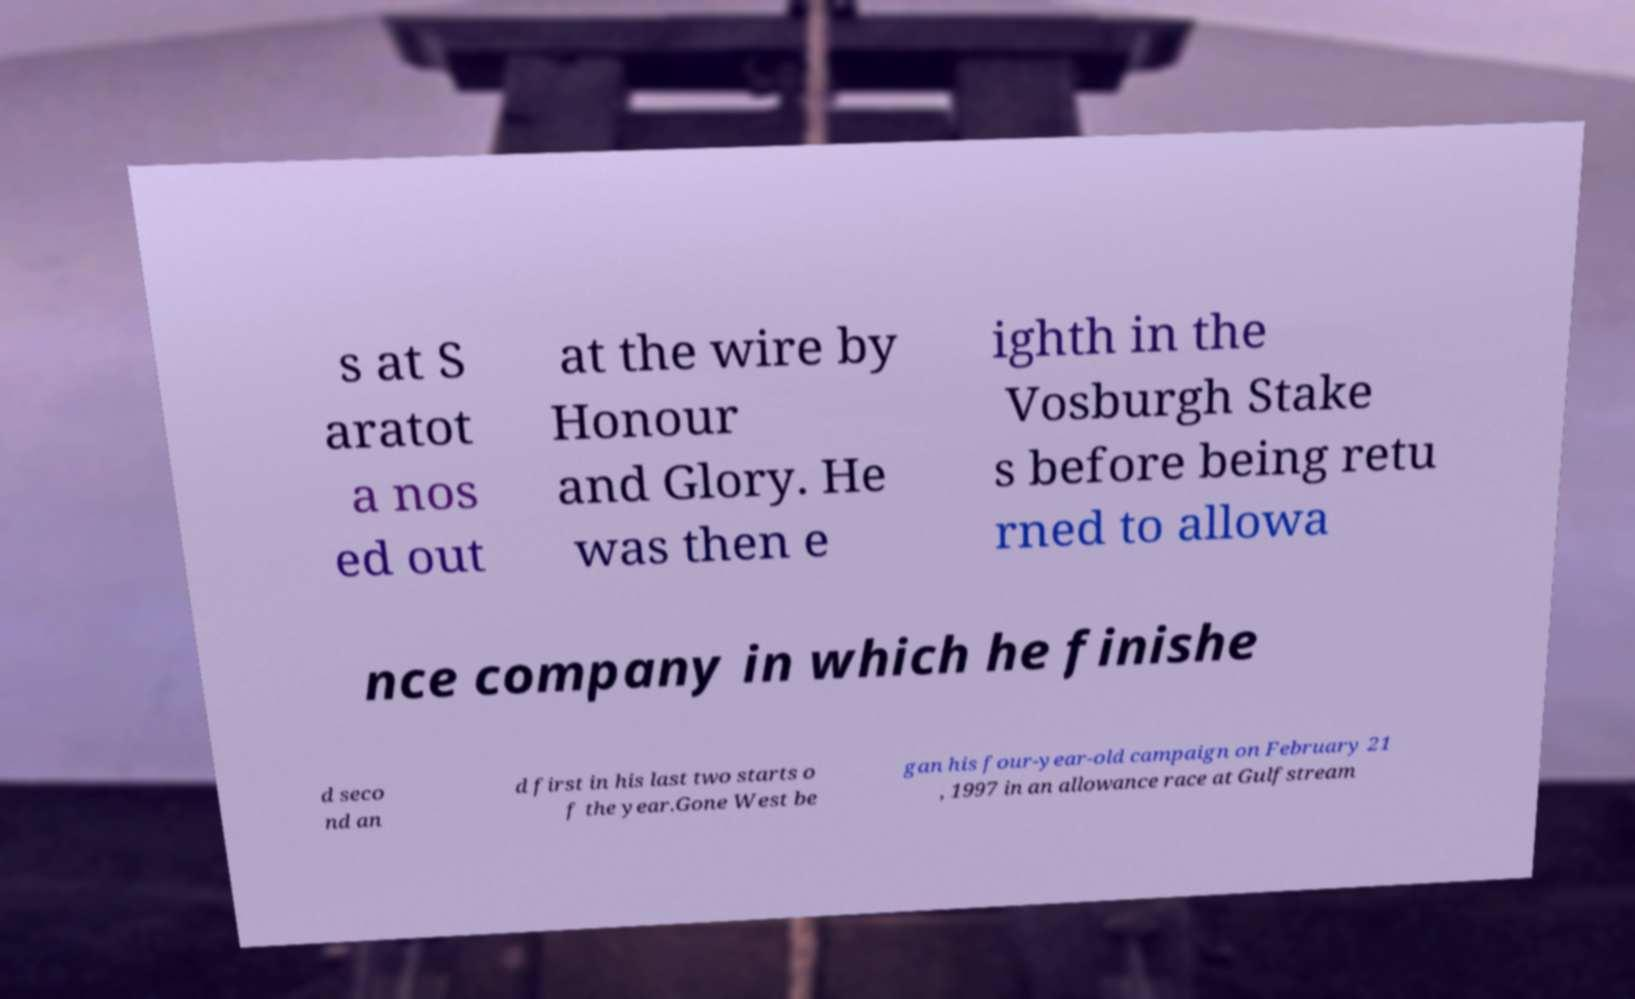What messages or text are displayed in this image? I need them in a readable, typed format. s at S aratot a nos ed out at the wire by Honour and Glory. He was then e ighth in the Vosburgh Stake s before being retu rned to allowa nce company in which he finishe d seco nd an d first in his last two starts o f the year.Gone West be gan his four-year-old campaign on February 21 , 1997 in an allowance race at Gulfstream 